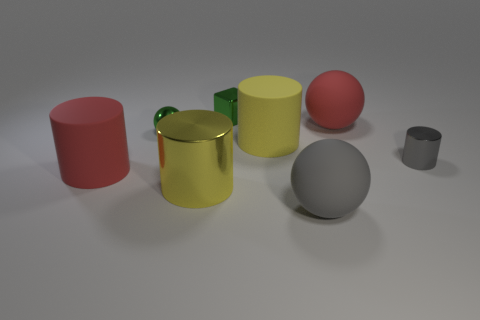Which objects in the picture would be more stable if a force were applied to them? The objects with a larger base area, such as the red and yellow cylinders, are likely to be more stable if a force were applied. Their wider base provides more surface area in contact with the ground, distributing the force and making them less prone to tipping over compared to the thinner cylinders or the spheres, which could roll away or topple more easily. 